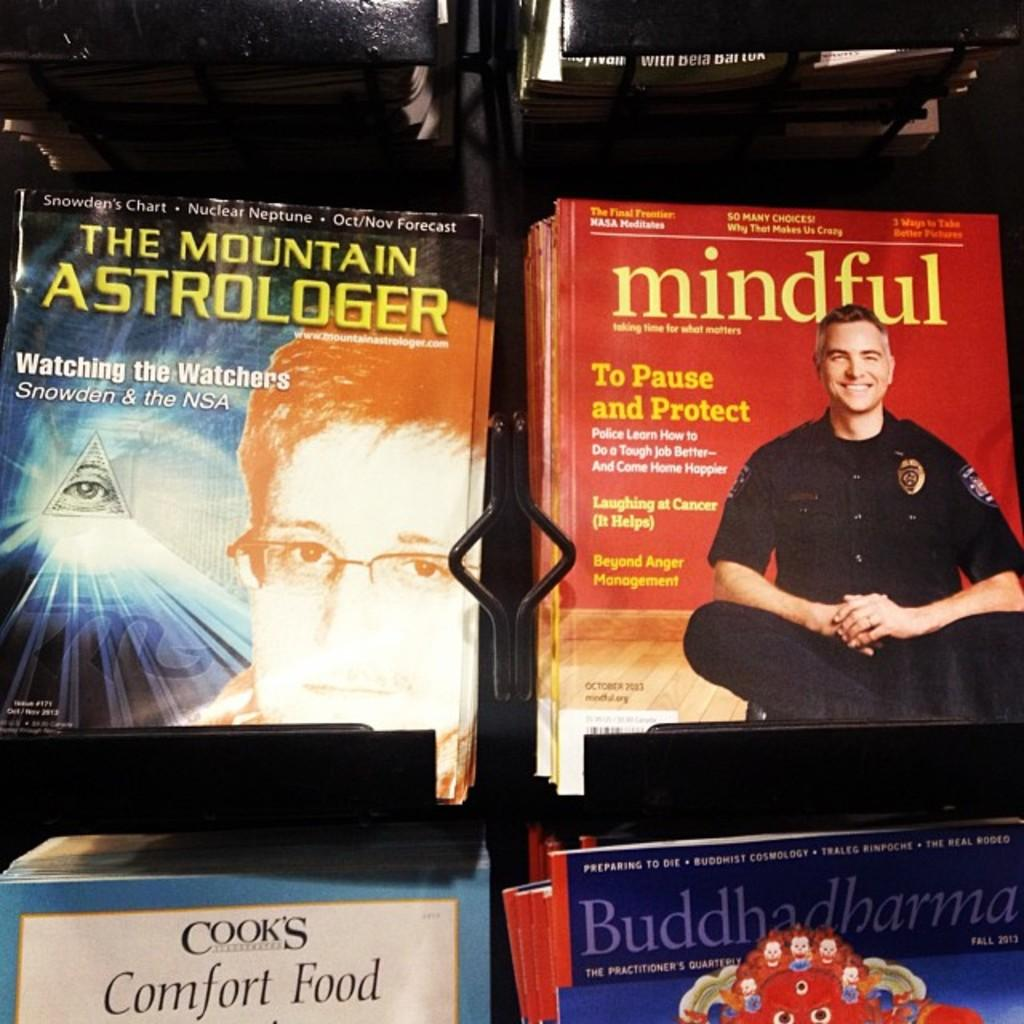Provide a one-sentence caption for the provided image. a book has the word mindful on the cover. 